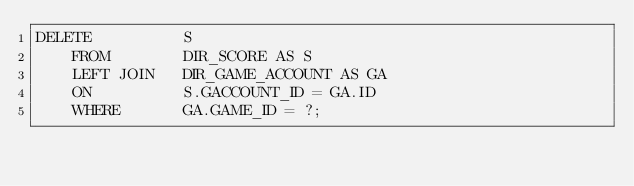Convert code to text. <code><loc_0><loc_0><loc_500><loc_500><_SQL_>DELETE			S
	FROM		DIR_SCORE AS S
	LEFT JOIN	DIR_GAME_ACCOUNT AS GA
	ON			S.GACCOUNT_ID = GA.ID
	WHERE		GA.GAME_ID = ?;
</code> 